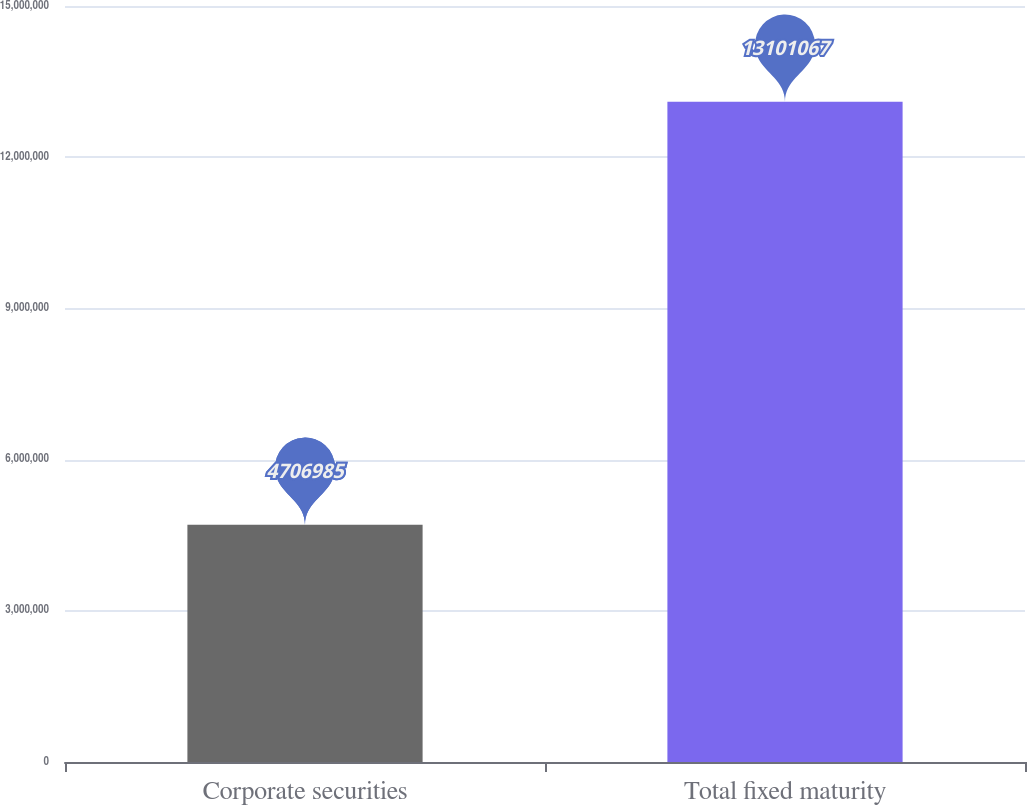Convert chart to OTSL. <chart><loc_0><loc_0><loc_500><loc_500><bar_chart><fcel>Corporate securities<fcel>Total fixed maturity<nl><fcel>4.70698e+06<fcel>1.31011e+07<nl></chart> 